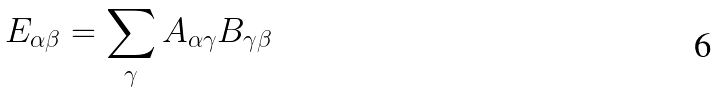<formula> <loc_0><loc_0><loc_500><loc_500>E _ { \alpha \beta } = \sum _ { \gamma } A _ { \alpha \gamma } B _ { \gamma \beta }</formula> 